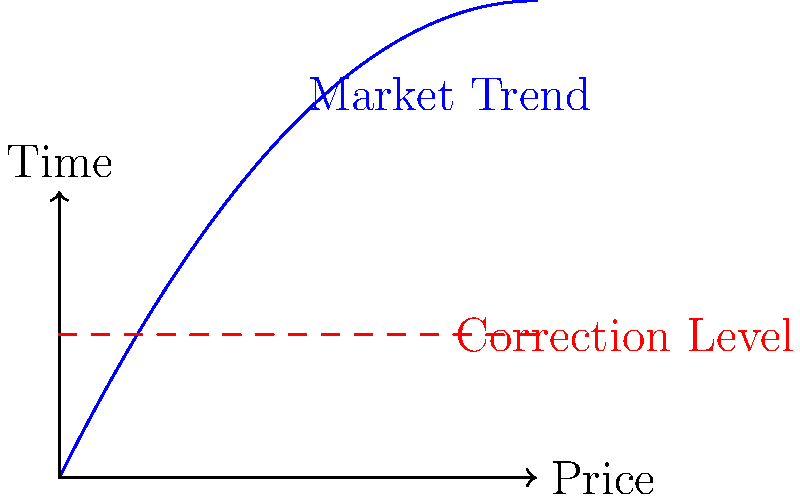A market trend is modeled by the function $P(t) = -0.2t^2 + 2t$, where $P$ represents the price and $t$ represents time in months. A market correction is expected when the price drops to $1.5$. After how many months will the market correction occur? To find when the market correction occurs, we need to solve the equation:

1. Set up the equation:
   $-0.2t^2 + 2t = 1.5$

2. Rearrange to standard quadratic form:
   $0.2t^2 - 2t + 1.5 = 0$

3. Use the quadratic formula: $t = \frac{-b \pm \sqrt{b^2 - 4ac}}{2a}$
   Where $a = 0.2$, $b = -2$, and $c = 1.5$

4. Substitute into the formula:
   $t = \frac{2 \pm \sqrt{(-2)^2 - 4(0.2)(1.5)}}{2(0.2)}$

5. Simplify:
   $t = \frac{2 \pm \sqrt{4 - 1.2}}{0.4} = \frac{2 \pm \sqrt{2.8}}{0.4}$

6. Calculate the two solutions:
   $t_1 = \frac{2 + \sqrt{2.8}}{0.4} \approx 8.66$ months
   $t_2 = \frac{2 - \sqrt{2.8}}{0.4} \approx 1.34$ months

7. Since we're looking for the future correction, we choose the positive solution that's greater than 0.

Therefore, the market correction will occur after approximately 8.66 months.
Answer: 8.66 months 